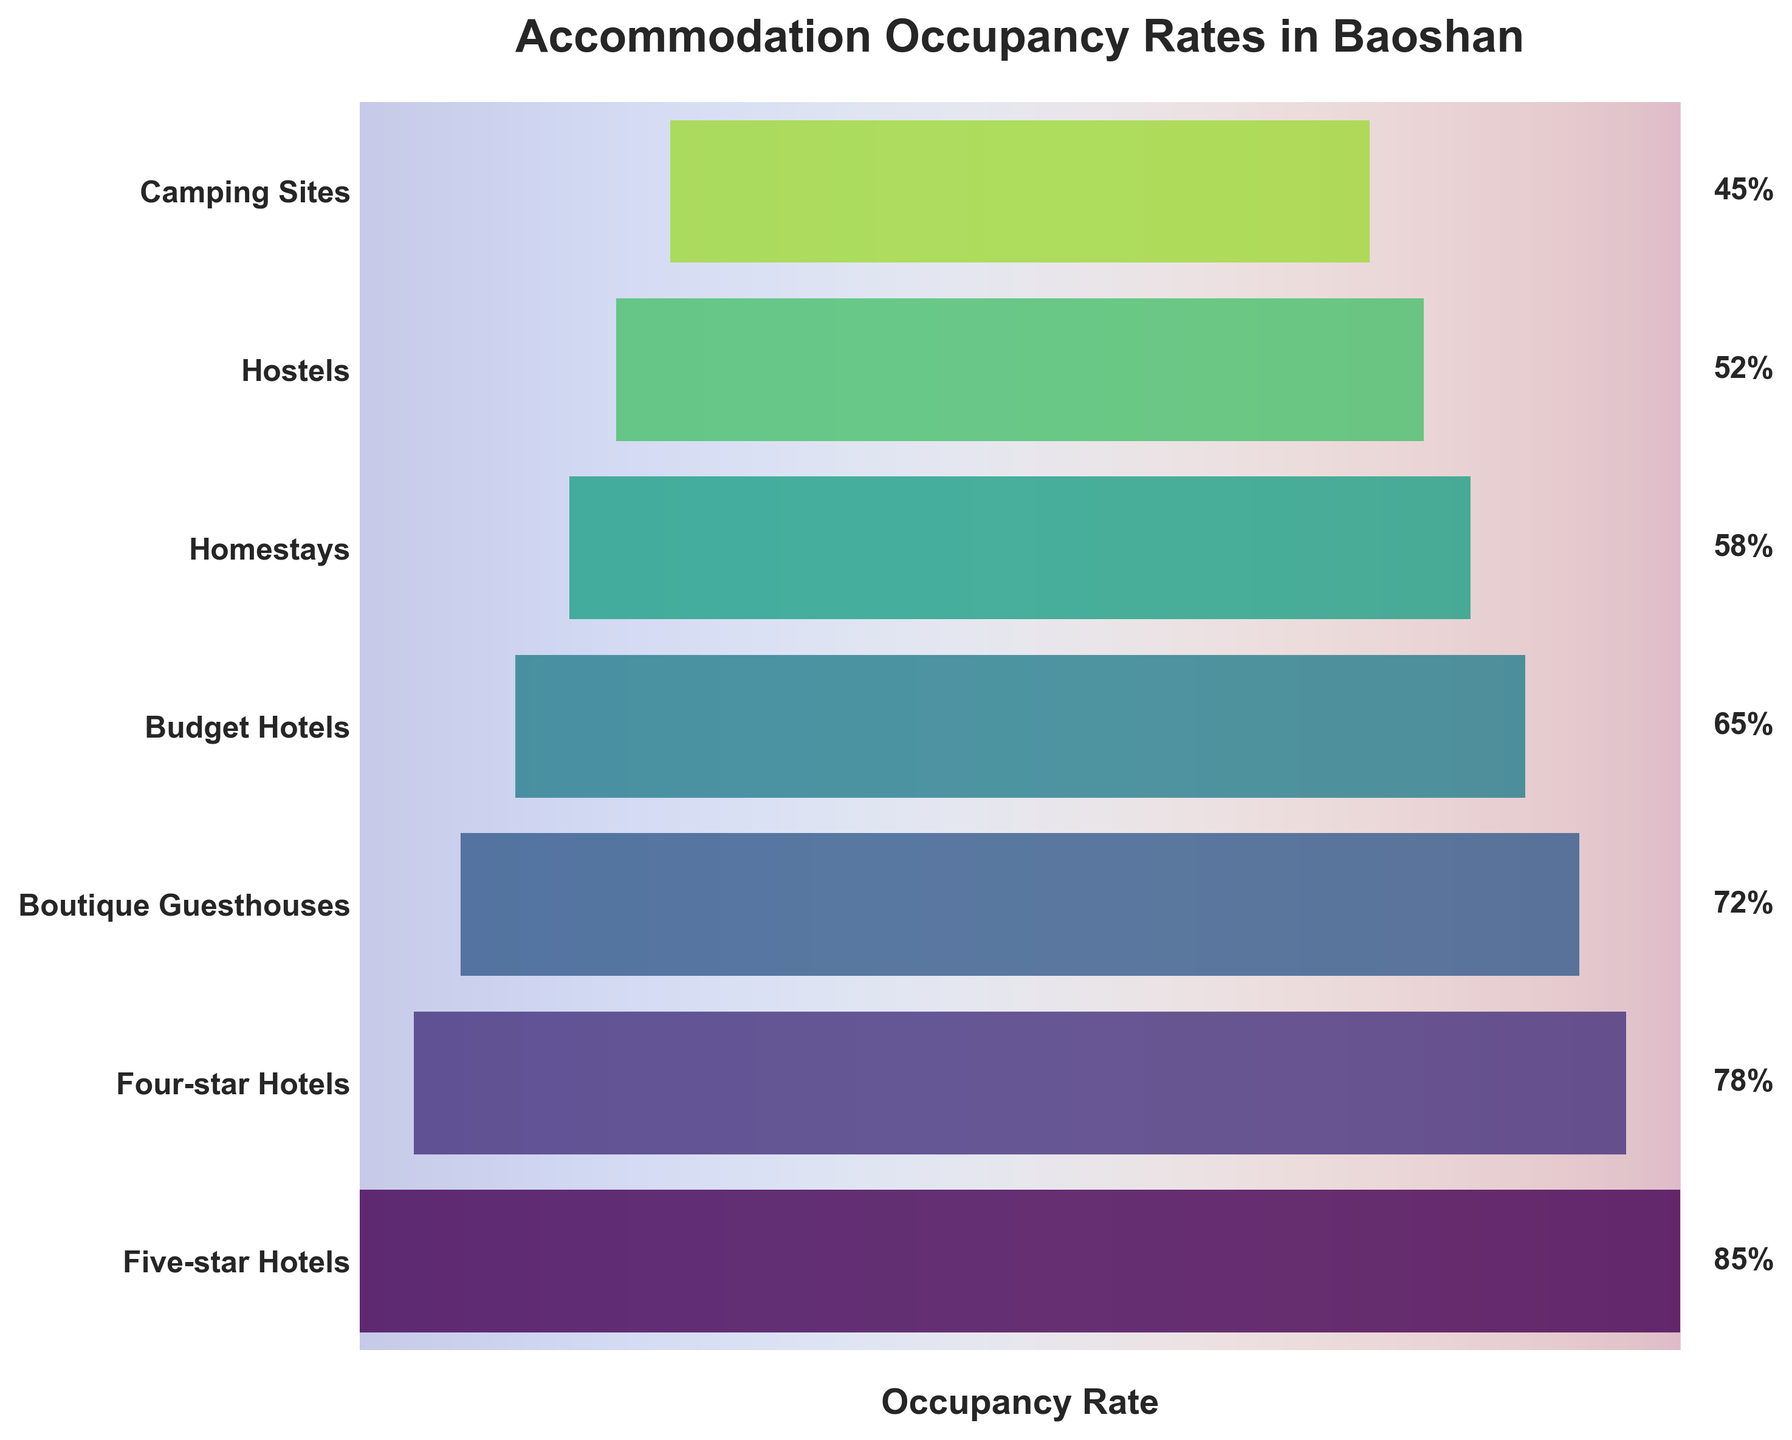How many types of accommodations are compared in the chart? Count the number of data points or bar sections in the funnel chart. Here we see data for Five-star Hotels, Four-star Hotels, Boutique Guesthouses, Budget Hotels, Homestays, Hostels, and Camping Sites. Thus, there are 7 types.
Answer: 7 Which accommodation type has the highest occupancy rate? The occupancy rate is indicated on the right side of the chart. The bar section at the top of the funnel chart represents the highest value. Checking the values, Five-star Hotels have the highest occupancy rate of 85%.
Answer: Five-star Hotels What is the difference in occupancy rate between Homestays and Hostels? Locate the occupancy rates for Homestays (58%) and Hostels (52%) on the chart. Subtract the smaller rate from the larger rate: 58% - 52% = 6%.
Answer: 6% Which two types of accommodations have the closest occupancy rates? By comparing the occupancy rates visually, look for the two sections of the funnel that have the most similar width. Boutique Guesthouses (72%) and Budget Hotels (65%) are relatively close.
Answer: Boutique Guesthouses and Budget Hotels What is the average occupancy rate among all accommodation types? Calculate the average by summing the occupancy rates and dividing by the total number of points. Rates: 85%, 78%, 72%, 65%, 58%, 52%, 45%. Sum = 455. Number of types = 7. Average = 455 / 7 ≈ 65%.
Answer: 65% Is the occupancy rate of Four-star Hotels greater than that of Boutique Guesthouses? Compare the occupancy rates of Four-star Hotels (78%) and Boutique Guesthouses (72%). Since 78% > 72%, the answer is yes.
Answer: Yes What is the median occupancy rate for all accommodation types? List the rates in ascending order: 45%, 52%, 58%, 65%, 72%, 78%, 85%. The median is the middle value when arranged in order, which is 65%.
Answer: 65% Which accommodation type has the lowest occupancy rate? The lowest section of the funnel chart represents the lowest value. Checking the values, Camping Sites have the lowest occupancy rate of 45%.
Answer: Camping Sites What's the range of occupancy rates across all accommodations in the chart? The range is found by subtracting the smallest value from the largest value. The highest rate is for Five-star Hotels (85%), and the lowest rate is for Camping Sites (45%). Range = 85% - 45% = 40%.
Answer: 40% How does the occupancy rate of Budget Hotels compare to that of Four-star Hotels? Compare the occupancy rates of Budget Hotels (65%) and Four-star Hotels (78%). Since 65% < 78%, the occupancy rate of Budget Hotels is less.
Answer: Less 